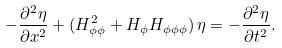Convert formula to latex. <formula><loc_0><loc_0><loc_500><loc_500>- \frac { \partial ^ { 2 } \eta } { \partial x ^ { 2 } } + ( H ^ { 2 } _ { \phi \phi } + H _ { \phi } H _ { \phi \phi \phi } ) \, \eta = - \frac { \partial ^ { 2 } \eta } { \partial t ^ { 2 } } .</formula> 